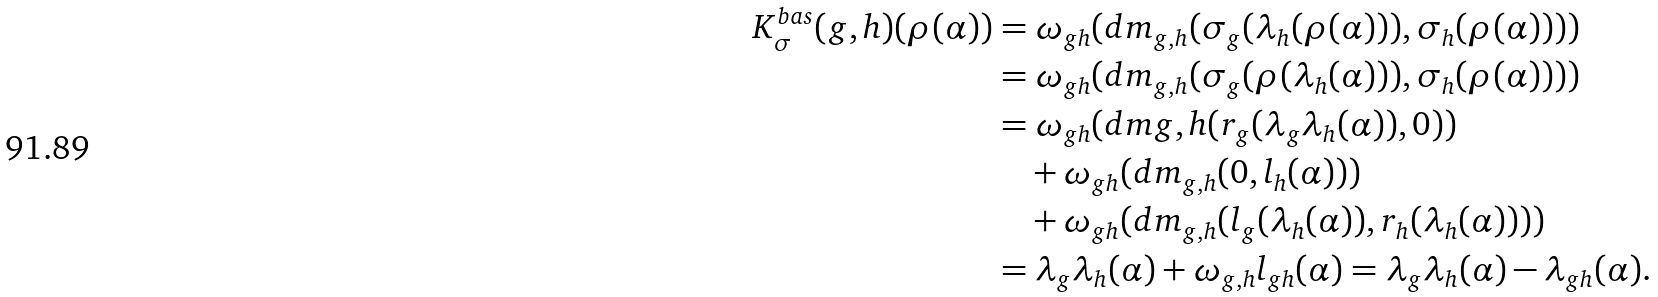Convert formula to latex. <formula><loc_0><loc_0><loc_500><loc_500>K ^ { b a s } _ { \sigma } ( g , h ) ( \rho ( \alpha ) ) & = \omega _ { g h } ( d m _ { g , h } ( \sigma _ { g } ( \lambda _ { h } ( \rho ( \alpha ) ) ) , \sigma _ { h } ( \rho ( \alpha ) ) ) ) \\ & = \omega _ { g h } ( d m _ { g , h } ( \sigma _ { g } ( \rho ( \lambda _ { h } ( \alpha ) ) ) , \sigma _ { h } ( \rho ( \alpha ) ) ) ) \\ & = \omega _ { g h } ( d m { g , h } ( r _ { g } ( \lambda _ { g } \lambda _ { h } ( \alpha ) ) , 0 ) ) \\ & \quad + \omega _ { g h } ( d m _ { g , h } ( 0 , l _ { h } ( \alpha ) ) ) \\ & \quad + \omega _ { g h } ( d m _ { g , h } ( l _ { g } ( \lambda _ { h } ( \alpha ) ) , r _ { h } ( \lambda _ { h } ( \alpha ) ) ) ) \\ & = \lambda _ { g } \lambda _ { h } ( \alpha ) + \omega _ { g , h } l _ { g h } ( \alpha ) = \lambda _ { g } \lambda _ { h } ( \alpha ) - \lambda _ { g h } ( \alpha ) .</formula> 